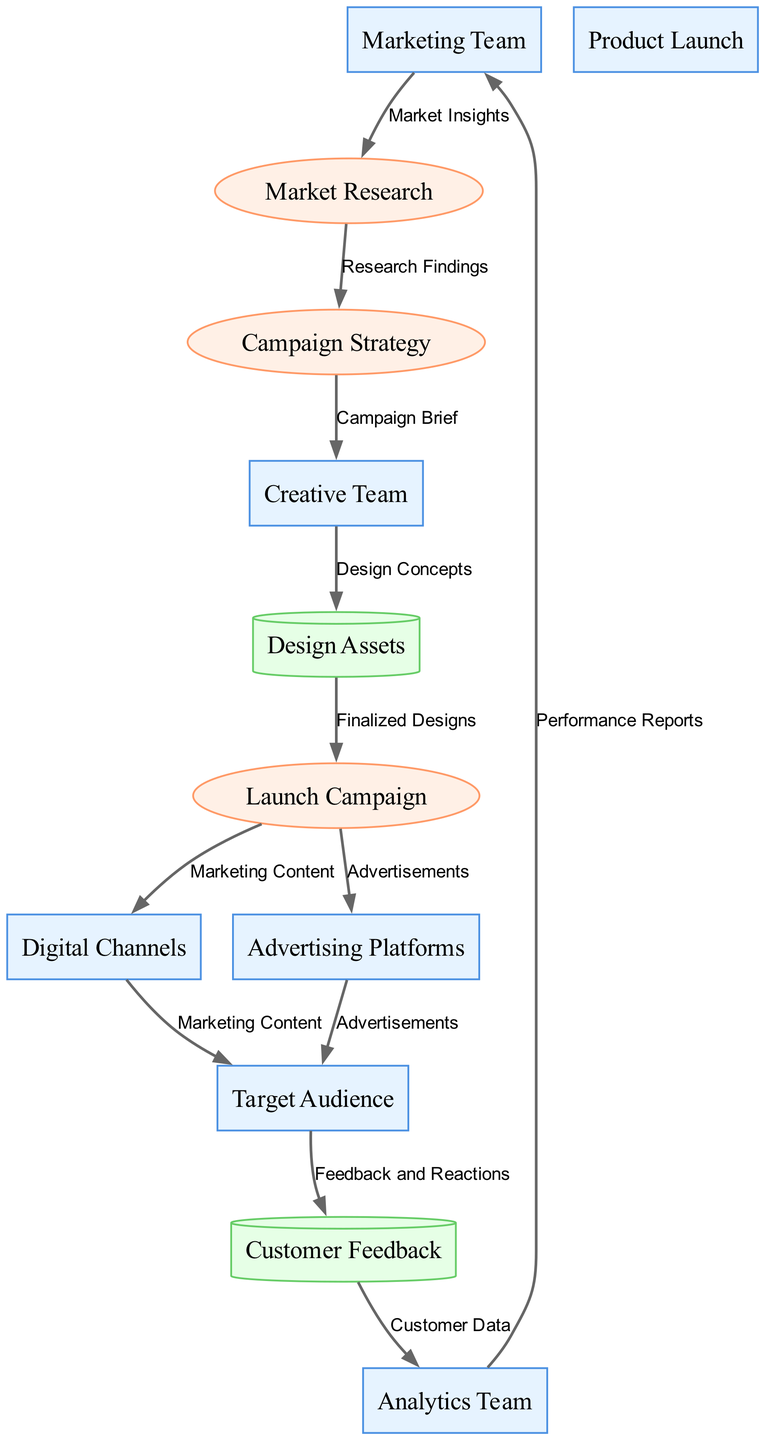What is the first process in the diagram? The first process that appears in the data flow diagram is the "Market Research," which receives input from the "Marketing Team."
Answer: Market Research How many external entities are depicted in the diagram? The diagram shows six external entities: "Marketing Team," "Target Audience," "Creative Team," "Digital Channels," "Advertising Platforms," and "Product Launch." Counting these gives us six entities.
Answer: 6 What data flows from the Campaign Strategy to the Creative Team? According to the data flow, the "Campaign Brief" is the data that flows from the "Campaign Strategy" process to the "Creative Team."
Answer: Campaign Brief Which process uses Design Assets? The "Launch Campaign" process uses "Design Assets," receiving the "Finalized Designs" from it.
Answer: Launch Campaign What type of entity is Customer Feedback? "Customer Feedback" is classified as a Data Store within the diagram, indicating it is a place where data is stored.
Answer: Data Store What is the last data flow in the diagram? The last data flow in the diagram is from the "Analytics Team" back to the "Marketing Team," providing "Performance Reports." This completes the flow of data related to the marketing campaign.
Answer: Performance Reports How many processes are included in the diagram? There are four processes in the diagram: "Market Research," "Campaign Strategy," "Launch Campaign," and the role of the "Creative Team" is implicit in the process but not separately listed. Counting these yields four distinct processes.
Answer: 4 Which entity receives feedback from the Target Audience? The "Customer Feedback" data store receives feedback from the "Target Audience," capturing their responses to the marketing efforts.
Answer: Customer Feedback What type of data flows from Digital Channels to Target Audience? The data flowing from "Digital Channels" to "Target Audience" consists of "Marketing Content," which is what the audience will see as part of the campaign.
Answer: Marketing Content 